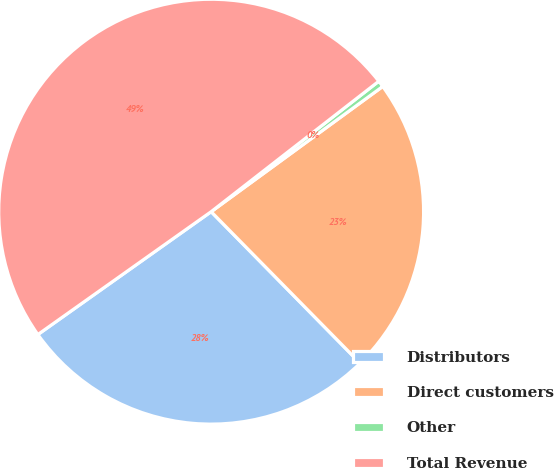<chart> <loc_0><loc_0><loc_500><loc_500><pie_chart><fcel>Distributors<fcel>Direct customers<fcel>Other<fcel>Total Revenue<nl><fcel>27.55%<fcel>22.67%<fcel>0.49%<fcel>49.29%<nl></chart> 